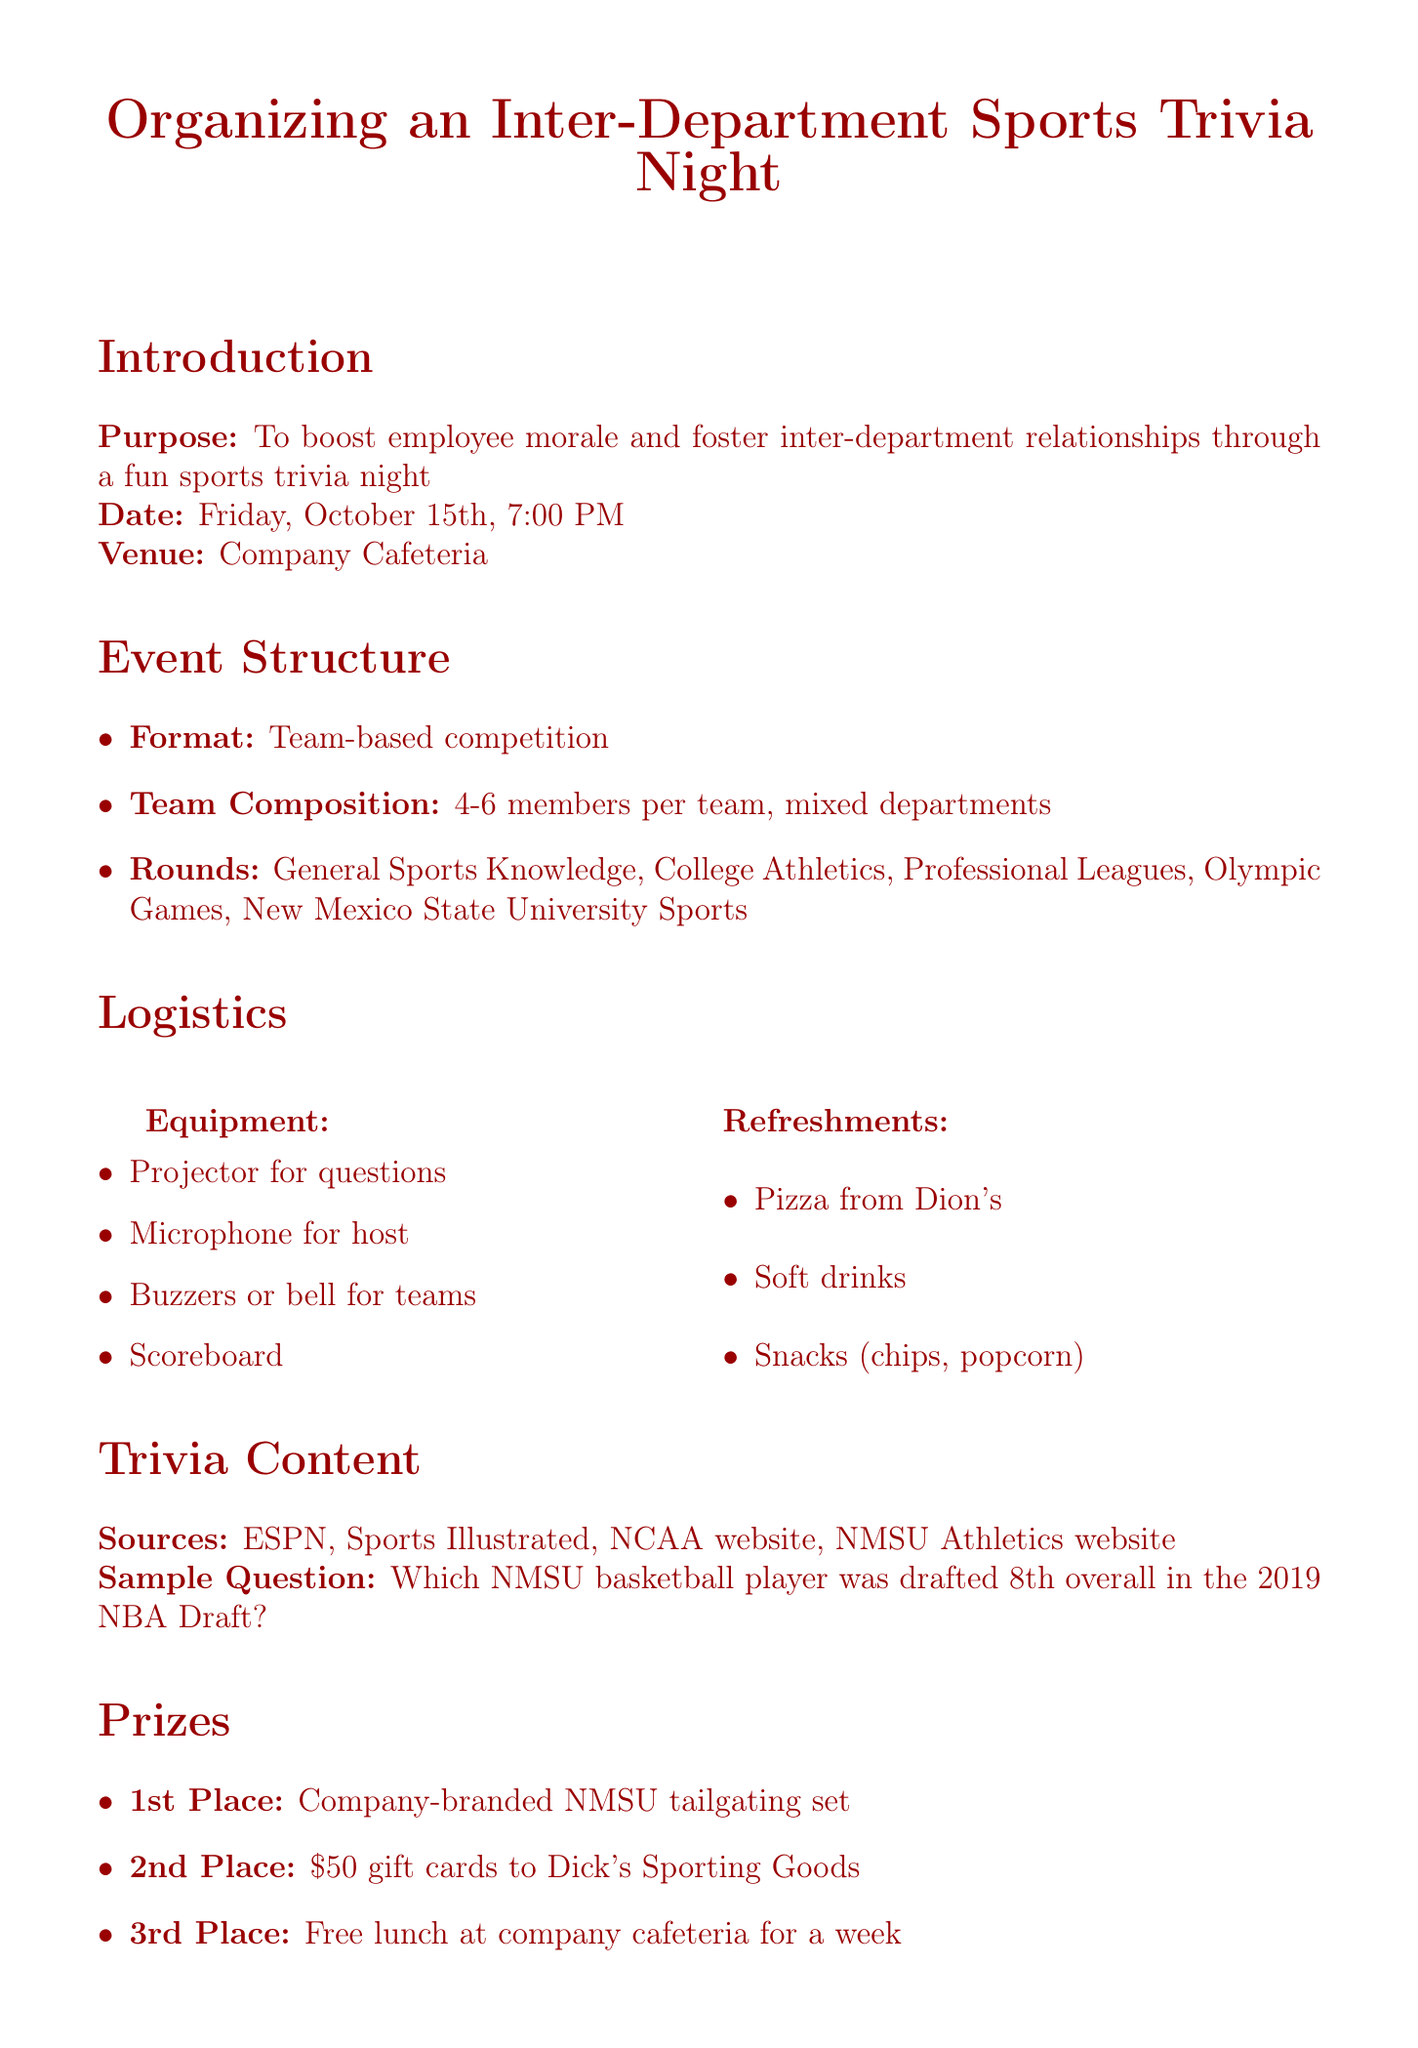What is the purpose of the event? The purpose of the event is to boost employee morale and foster inter-department relationships through a fun sports trivia night.
Answer: To boost employee morale and foster inter-department relationships What is the proposed date for the trivia night? The proposed date can be directly found under the introduction section of the document.
Answer: Friday, October 15th, 7:00 PM How many members are allowed per team? This information is found under the event structure section detailing team composition.
Answer: 4-6 members per team What is the total budget allocated for the event? The total budget summary is listed in the budget section of the document.
Answer: $1,000 Which company provides pizza for the refreshments? This information is found in the logistics section regarding refreshments for the event.
Answer: Dion's What is one of the sample trivia questions included? The sample question provided in the trivia content section can be used here as specific content.
Answer: Which NMSU basketball player was drafted 8th overall in the 2019 NBA Draft? Who is responsible for technical support during the event? The organization committee section lists the individuals and their roles, including technical support.
Answer: Mike Rodriguez What is the first place prize for the trivia night? The prizes section details the awards for the tournament placement, starting with first place.
Answer: Company-branded New Mexico State University tailgating set Which channels are planned for promoting the event? The promotion plan section lists the channels for sharing information about the event.
Answer: Company-wide email, Slack announcements, Posters, Department meetings 